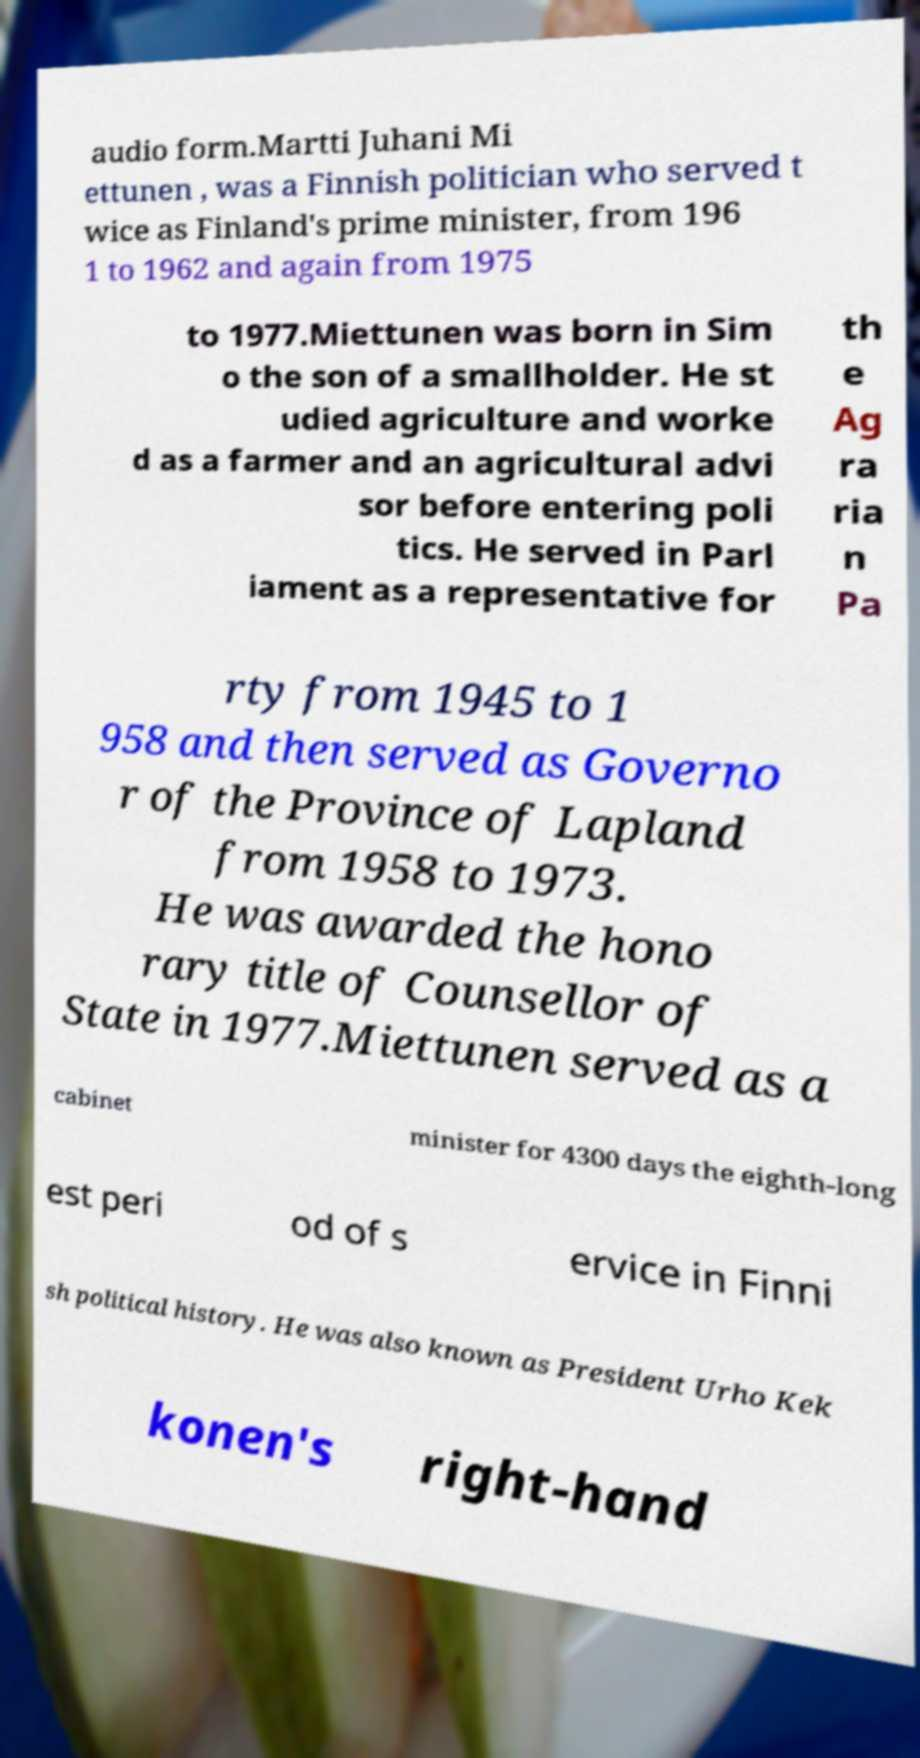Please read and relay the text visible in this image. What does it say? audio form.Martti Juhani Mi ettunen , was a Finnish politician who served t wice as Finland's prime minister, from 196 1 to 1962 and again from 1975 to 1977.Miettunen was born in Sim o the son of a smallholder. He st udied agriculture and worke d as a farmer and an agricultural advi sor before entering poli tics. He served in Parl iament as a representative for th e Ag ra ria n Pa rty from 1945 to 1 958 and then served as Governo r of the Province of Lapland from 1958 to 1973. He was awarded the hono rary title of Counsellor of State in 1977.Miettunen served as a cabinet minister for 4300 days the eighth-long est peri od of s ervice in Finni sh political history. He was also known as President Urho Kek konen's right-hand 